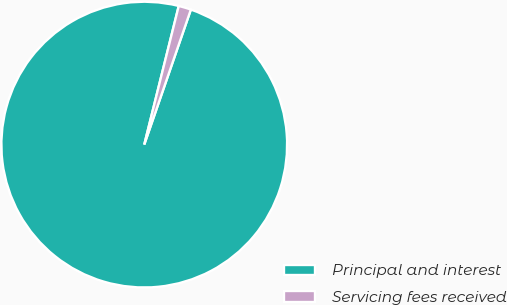<chart> <loc_0><loc_0><loc_500><loc_500><pie_chart><fcel>Principal and interest<fcel>Servicing fees received<nl><fcel>98.59%<fcel>1.41%<nl></chart> 